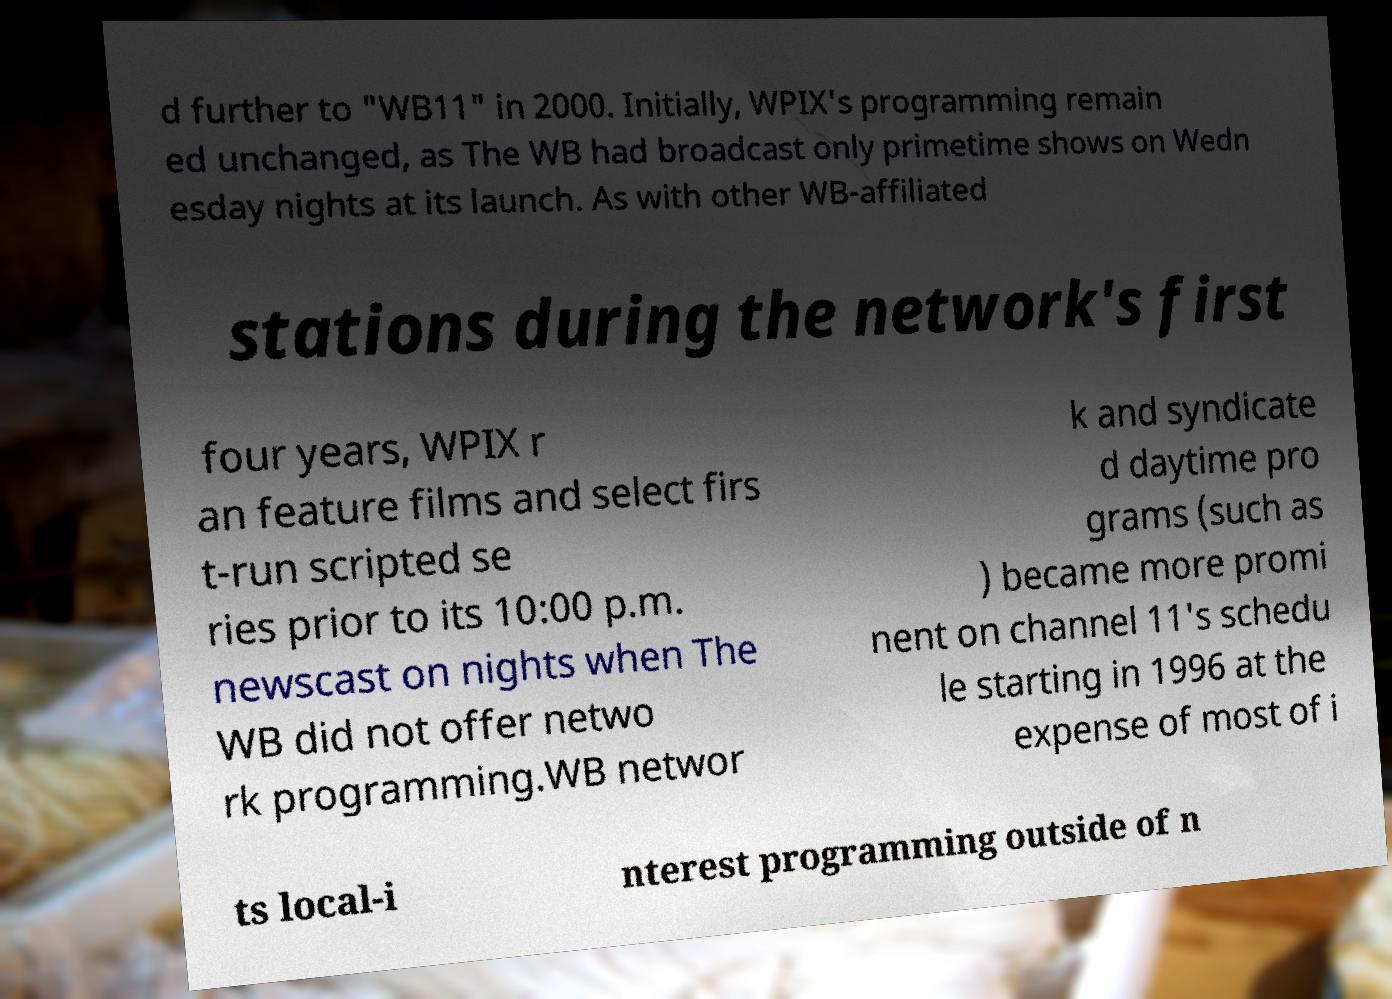Could you assist in decoding the text presented in this image and type it out clearly? d further to "WB11" in 2000. Initially, WPIX's programming remain ed unchanged, as The WB had broadcast only primetime shows on Wedn esday nights at its launch. As with other WB-affiliated stations during the network's first four years, WPIX r an feature films and select firs t-run scripted se ries prior to its 10:00 p.m. newscast on nights when The WB did not offer netwo rk programming.WB networ k and syndicate d daytime pro grams (such as ) became more promi nent on channel 11's schedu le starting in 1996 at the expense of most of i ts local-i nterest programming outside of n 